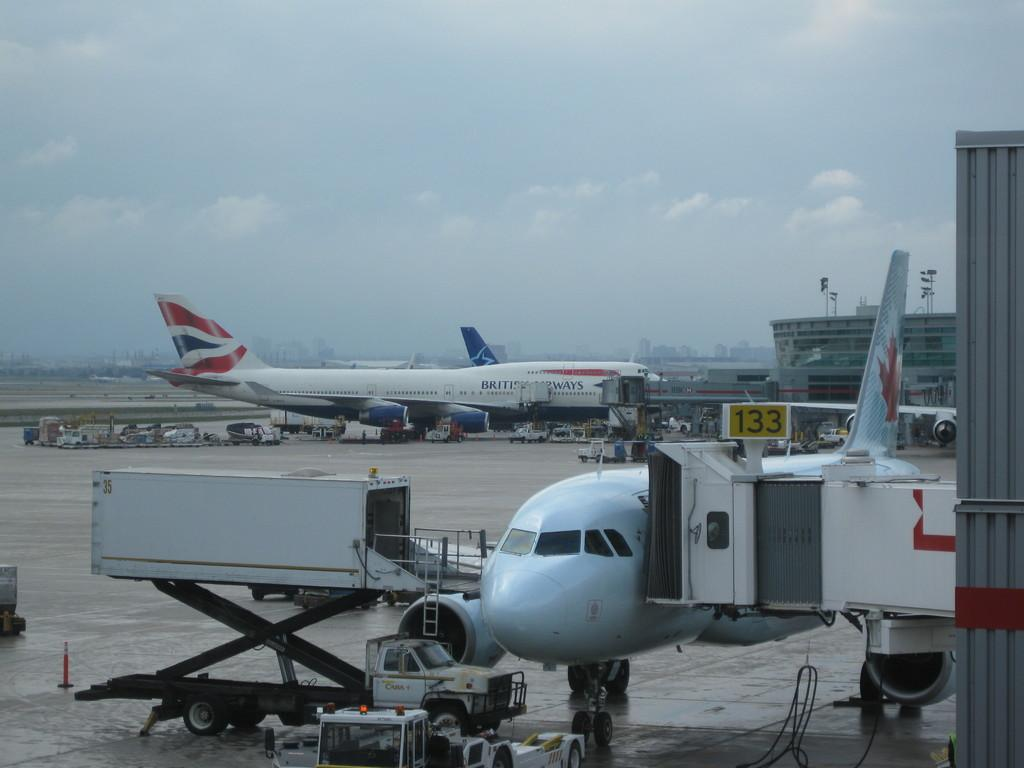<image>
Describe the image concisely. An airplane is pulled up to the gate in front of the gate numbered 133. 